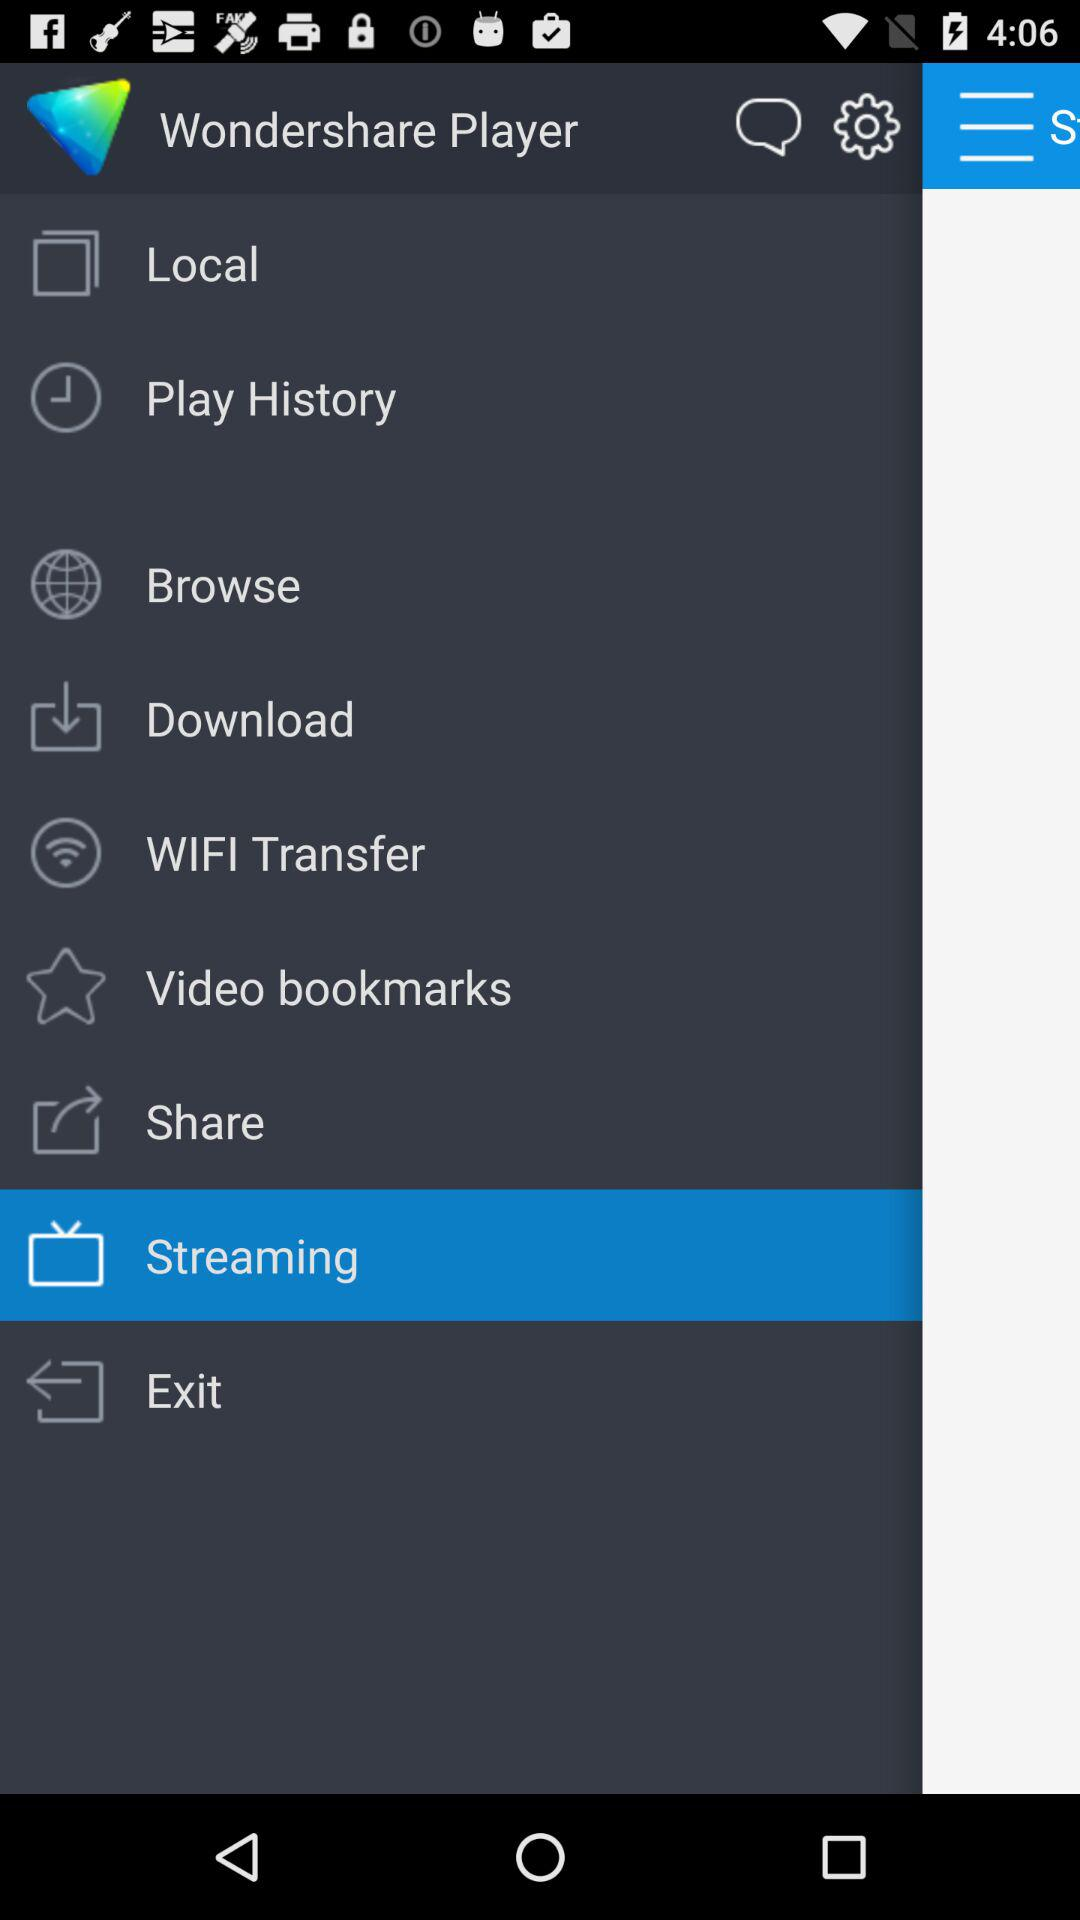Which item has been selected? The item that has been selected is "Streaming". 